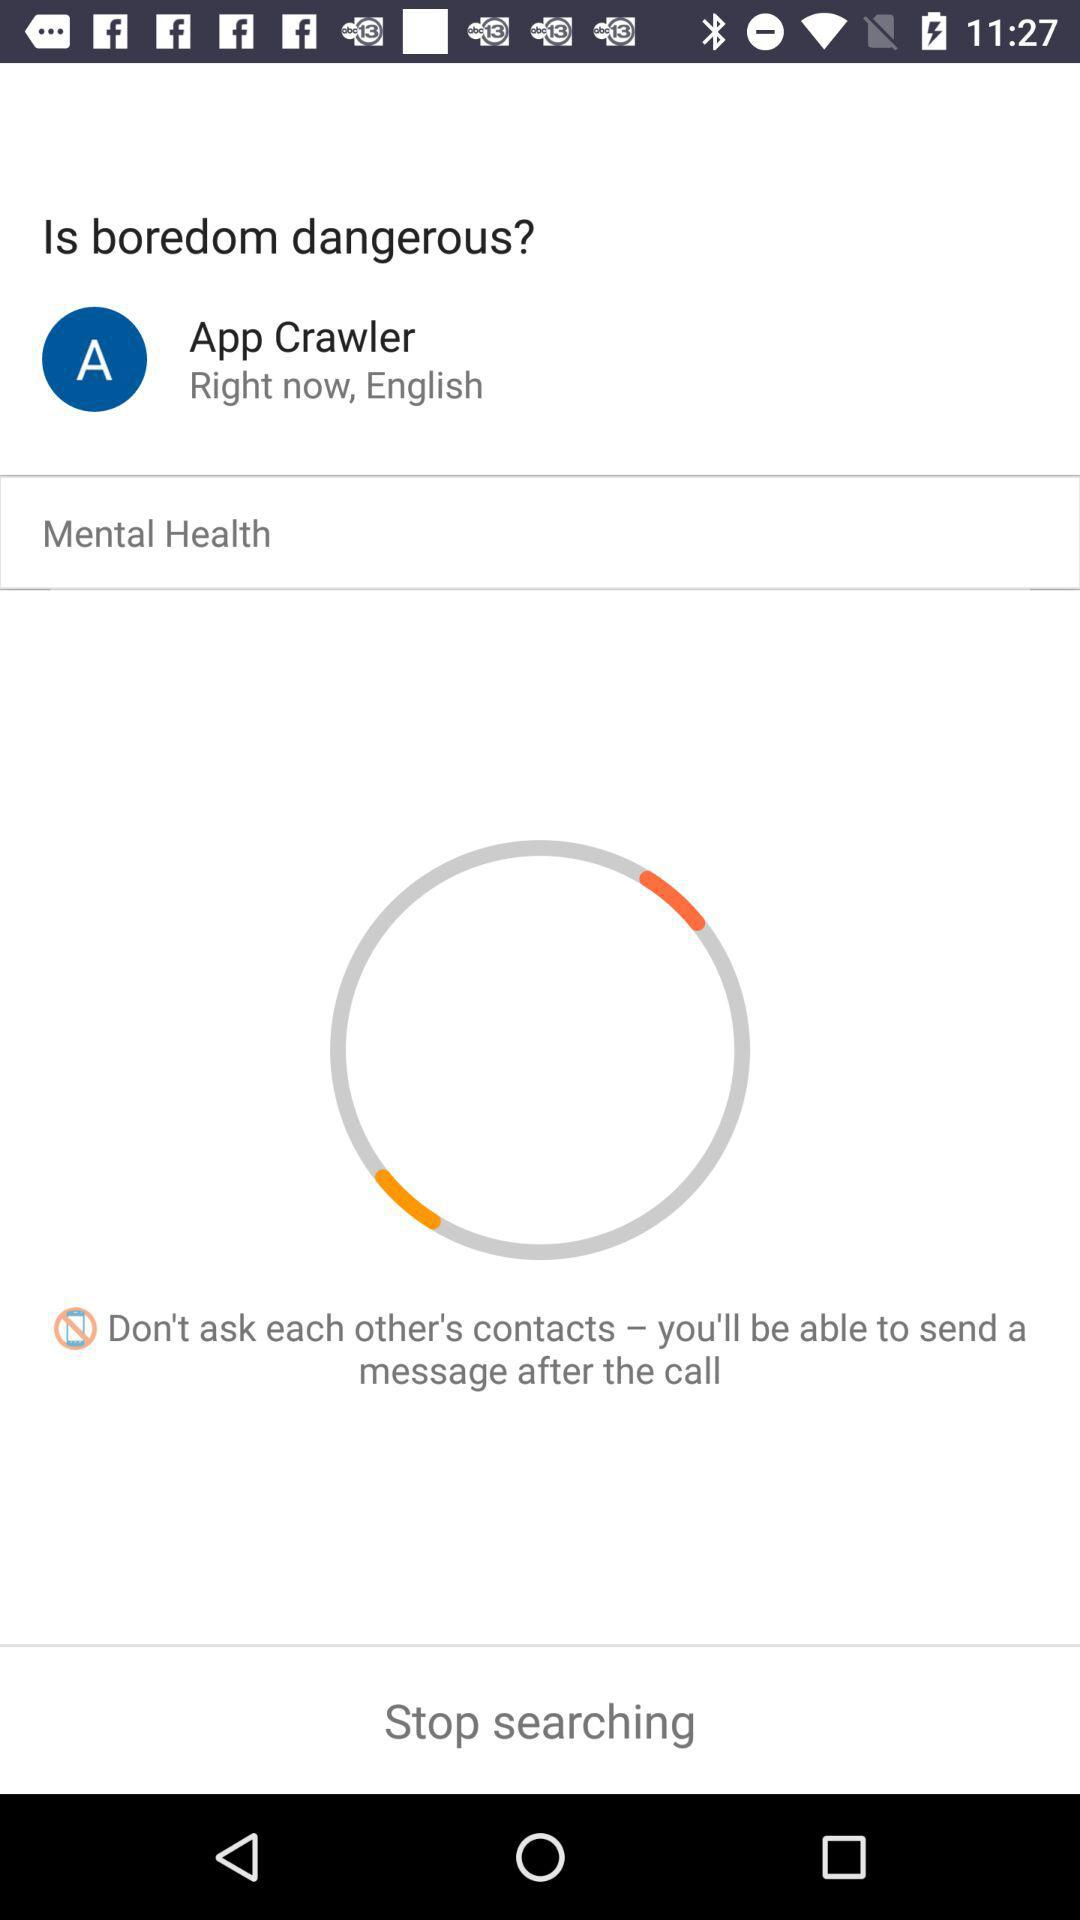Which language is mentioned? The mentioned language is English. 